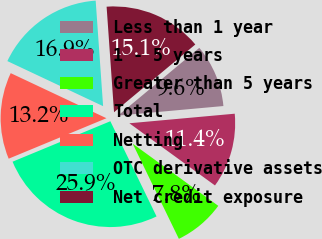Convert chart. <chart><loc_0><loc_0><loc_500><loc_500><pie_chart><fcel>Less than 1 year<fcel>1 - 5 years<fcel>Greater than 5 years<fcel>Total<fcel>Netting<fcel>OTC derivative assets<fcel>Net credit exposure<nl><fcel>9.62%<fcel>11.44%<fcel>7.81%<fcel>25.95%<fcel>13.25%<fcel>16.88%<fcel>15.06%<nl></chart> 